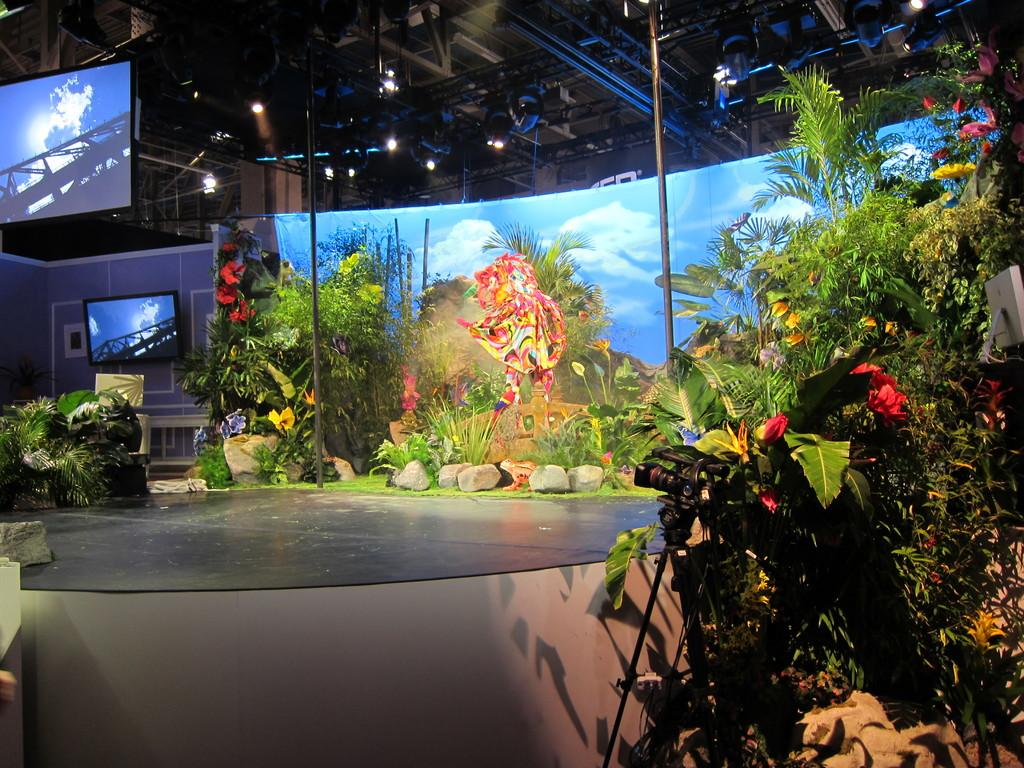What is the main structure in the image? There is a platform in the image. What type of objects can be seen on the platform? There are stones and flowers on the platform. What other structures are present in the image? There are poles and walls in the image. What is hanging from the poles? There is a banner hanging from the poles. What electronic devices are visible in the image? There are televisions in the image. What can be seen in the background of the image? In the background, there are lights and rods visible. How many oranges are placed in the pocket of the person in the image? There is no person present in the image, and therefore no pocket or oranges can be observed. 